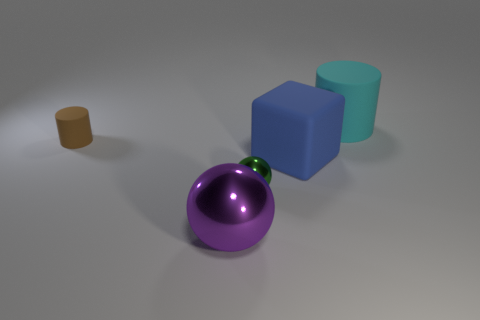Add 1 large yellow rubber cubes. How many objects exist? 6 Subtract all cylinders. How many objects are left? 3 Add 2 large purple balls. How many large purple balls are left? 3 Add 1 large matte blocks. How many large matte blocks exist? 2 Subtract 0 cyan spheres. How many objects are left? 5 Subtract all rubber cylinders. Subtract all brown matte objects. How many objects are left? 2 